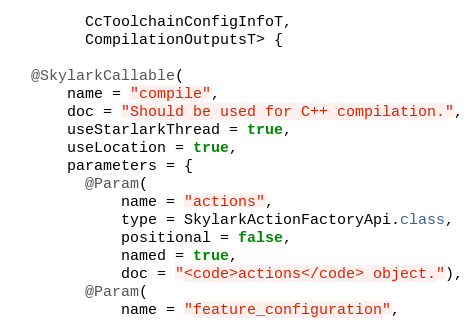Convert code to text. <code><loc_0><loc_0><loc_500><loc_500><_Java_>        CcToolchainConfigInfoT,
        CompilationOutputsT> {

  @SkylarkCallable(
      name = "compile",
      doc = "Should be used for C++ compilation.",
      useStarlarkThread = true,
      useLocation = true,
      parameters = {
        @Param(
            name = "actions",
            type = SkylarkActionFactoryApi.class,
            positional = false,
            named = true,
            doc = "<code>actions</code> object."),
        @Param(
            name = "feature_configuration",</code> 